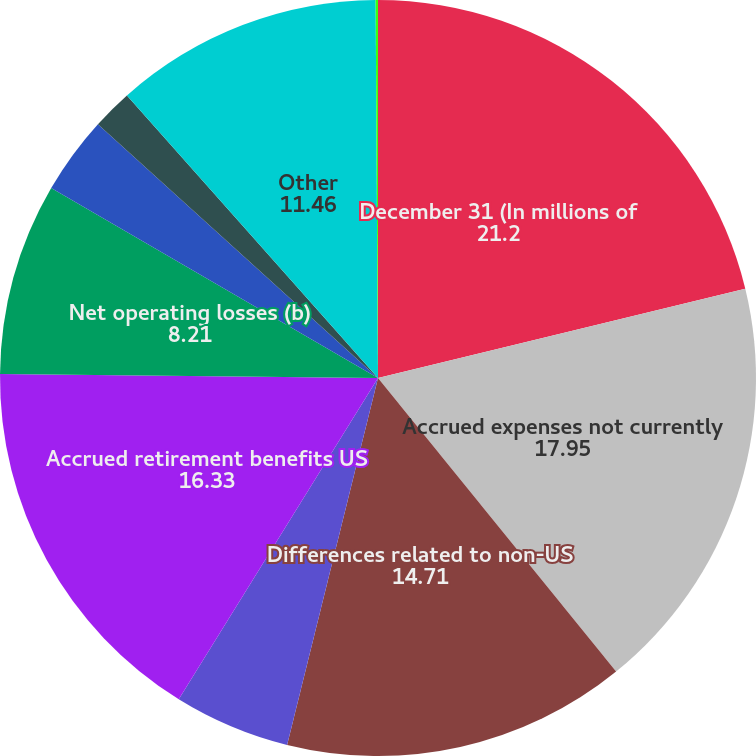Convert chart to OTSL. <chart><loc_0><loc_0><loc_500><loc_500><pie_chart><fcel>December 31 (In millions of<fcel>Accrued expenses not currently<fcel>Differences related to non-US<fcel>Accrued retirement &<fcel>Accrued retirement benefits US<fcel>Net operating losses (b)<fcel>Income currently recognized<fcel>Foreign tax credit<fcel>Other<fcel>Unrealizedinvestment<nl><fcel>21.2%<fcel>17.95%<fcel>14.71%<fcel>4.97%<fcel>16.33%<fcel>8.21%<fcel>3.34%<fcel>1.72%<fcel>11.46%<fcel>0.1%<nl></chart> 